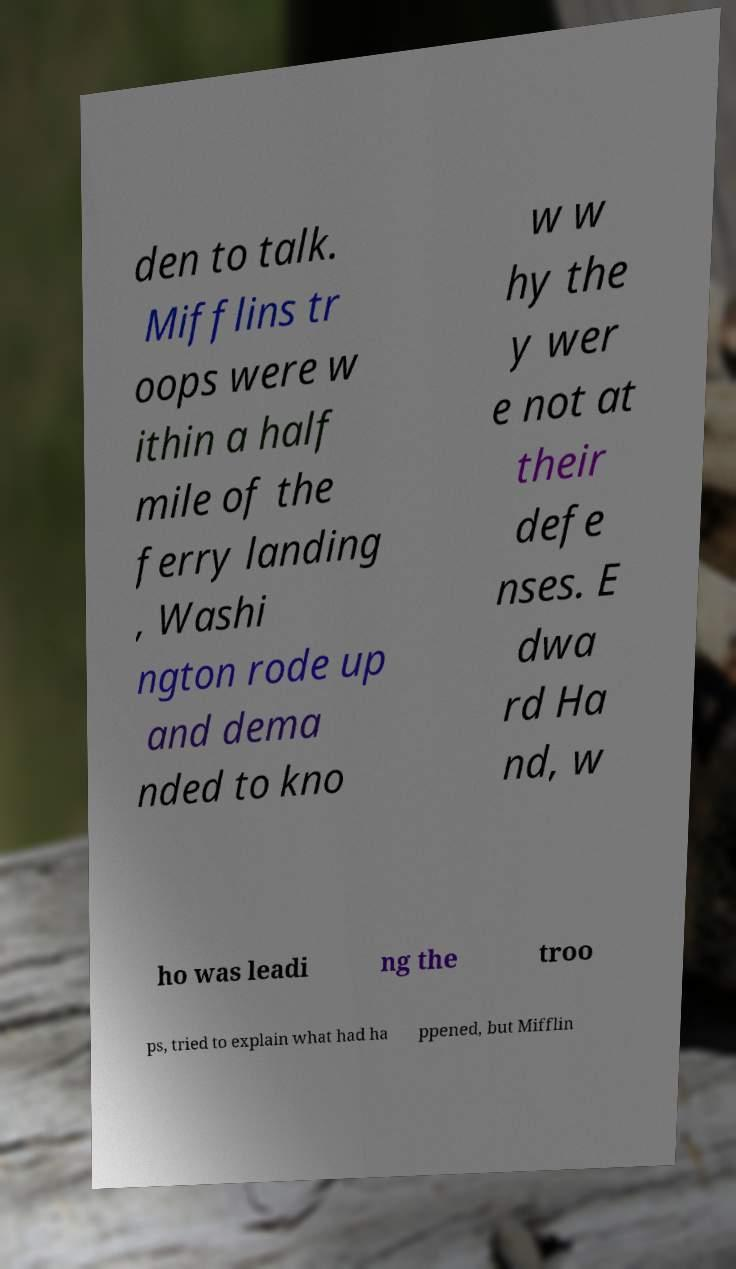For documentation purposes, I need the text within this image transcribed. Could you provide that? den to talk. Mifflins tr oops were w ithin a half mile of the ferry landing , Washi ngton rode up and dema nded to kno w w hy the y wer e not at their defe nses. E dwa rd Ha nd, w ho was leadi ng the troo ps, tried to explain what had ha ppened, but Mifflin 